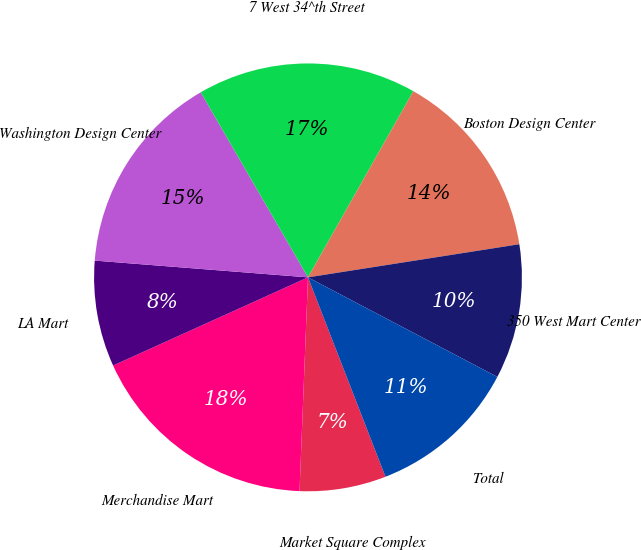Convert chart to OTSL. <chart><loc_0><loc_0><loc_500><loc_500><pie_chart><fcel>Market Square Complex<fcel>Merchandise Mart<fcel>LA Mart<fcel>Washington Design Center<fcel>7 West 34^th Street<fcel>Boston Design Center<fcel>350 West Mart Center<fcel>Total<nl><fcel>6.53%<fcel>17.61%<fcel>8.01%<fcel>15.39%<fcel>16.56%<fcel>14.33%<fcel>10.18%<fcel>11.4%<nl></chart> 